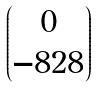Convert formula to latex. <formula><loc_0><loc_0><loc_500><loc_500>\begin{pmatrix} 0 \\ - 8 2 8 \end{pmatrix}</formula> 